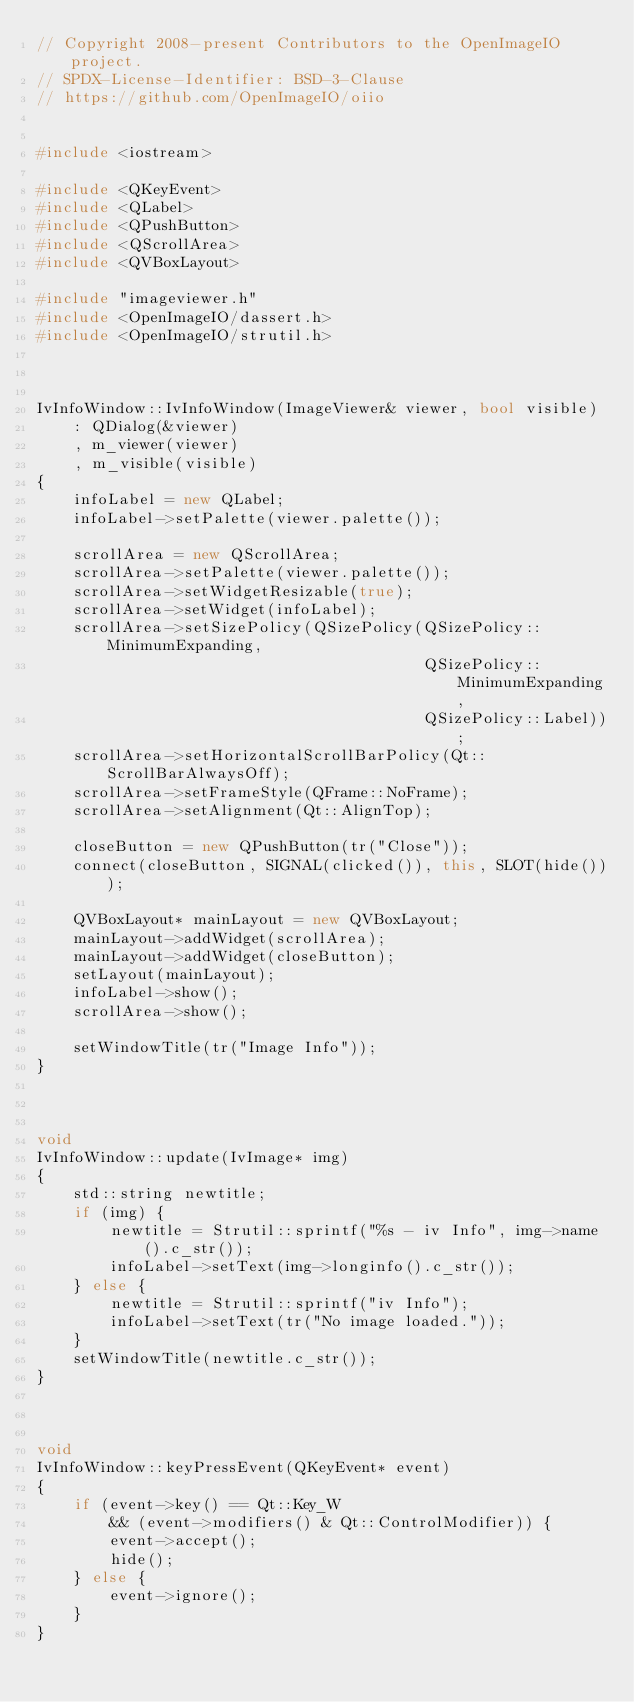<code> <loc_0><loc_0><loc_500><loc_500><_C++_>// Copyright 2008-present Contributors to the OpenImageIO project.
// SPDX-License-Identifier: BSD-3-Clause
// https://github.com/OpenImageIO/oiio


#include <iostream>

#include <QKeyEvent>
#include <QLabel>
#include <QPushButton>
#include <QScrollArea>
#include <QVBoxLayout>

#include "imageviewer.h"
#include <OpenImageIO/dassert.h>
#include <OpenImageIO/strutil.h>



IvInfoWindow::IvInfoWindow(ImageViewer& viewer, bool visible)
    : QDialog(&viewer)
    , m_viewer(viewer)
    , m_visible(visible)
{
    infoLabel = new QLabel;
    infoLabel->setPalette(viewer.palette());

    scrollArea = new QScrollArea;
    scrollArea->setPalette(viewer.palette());
    scrollArea->setWidgetResizable(true);
    scrollArea->setWidget(infoLabel);
    scrollArea->setSizePolicy(QSizePolicy(QSizePolicy::MinimumExpanding,
                                          QSizePolicy::MinimumExpanding,
                                          QSizePolicy::Label));
    scrollArea->setHorizontalScrollBarPolicy(Qt::ScrollBarAlwaysOff);
    scrollArea->setFrameStyle(QFrame::NoFrame);
    scrollArea->setAlignment(Qt::AlignTop);

    closeButton = new QPushButton(tr("Close"));
    connect(closeButton, SIGNAL(clicked()), this, SLOT(hide()));

    QVBoxLayout* mainLayout = new QVBoxLayout;
    mainLayout->addWidget(scrollArea);
    mainLayout->addWidget(closeButton);
    setLayout(mainLayout);
    infoLabel->show();
    scrollArea->show();

    setWindowTitle(tr("Image Info"));
}



void
IvInfoWindow::update(IvImage* img)
{
    std::string newtitle;
    if (img) {
        newtitle = Strutil::sprintf("%s - iv Info", img->name().c_str());
        infoLabel->setText(img->longinfo().c_str());
    } else {
        newtitle = Strutil::sprintf("iv Info");
        infoLabel->setText(tr("No image loaded."));
    }
    setWindowTitle(newtitle.c_str());
}



void
IvInfoWindow::keyPressEvent(QKeyEvent* event)
{
    if (event->key() == Qt::Key_W
        && (event->modifiers() & Qt::ControlModifier)) {
        event->accept();
        hide();
    } else {
        event->ignore();
    }
}
</code> 